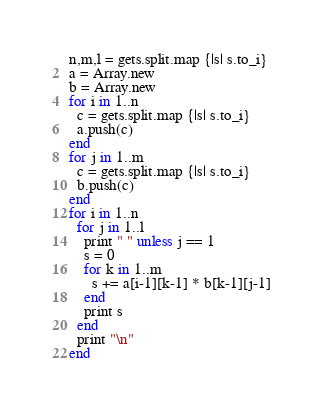<code> <loc_0><loc_0><loc_500><loc_500><_Ruby_>n,m,l = gets.split.map {|s| s.to_i}
a = Array.new
b = Array.new
for i in 1..n
  c = gets.split.map {|s| s.to_i}
  a.push(c)
end
for j in 1..m
  c = gets.split.map {|s| s.to_i}
  b.push(c)
end
for i in 1..n
  for j in 1..l
    print " " unless j == 1
    s = 0
    for k in 1..m
      s += a[i-1][k-1] * b[k-1][j-1]
    end
    print s
  end
  print "\n"
end
</code> 